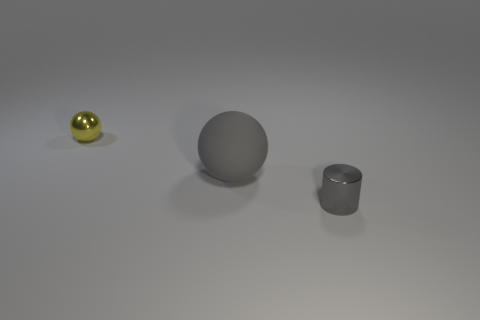Subtract all gray spheres. How many spheres are left? 1 Add 1 small gray metallic cylinders. How many objects exist? 4 Subtract all balls. How many objects are left? 1 Subtract all gray matte spheres. Subtract all tiny gray metallic cylinders. How many objects are left? 1 Add 3 small metal balls. How many small metal balls are left? 4 Add 3 tiny red balls. How many tiny red balls exist? 3 Subtract 0 brown balls. How many objects are left? 3 Subtract 1 cylinders. How many cylinders are left? 0 Subtract all brown balls. Subtract all gray blocks. How many balls are left? 2 Subtract all blue cubes. How many gray balls are left? 1 